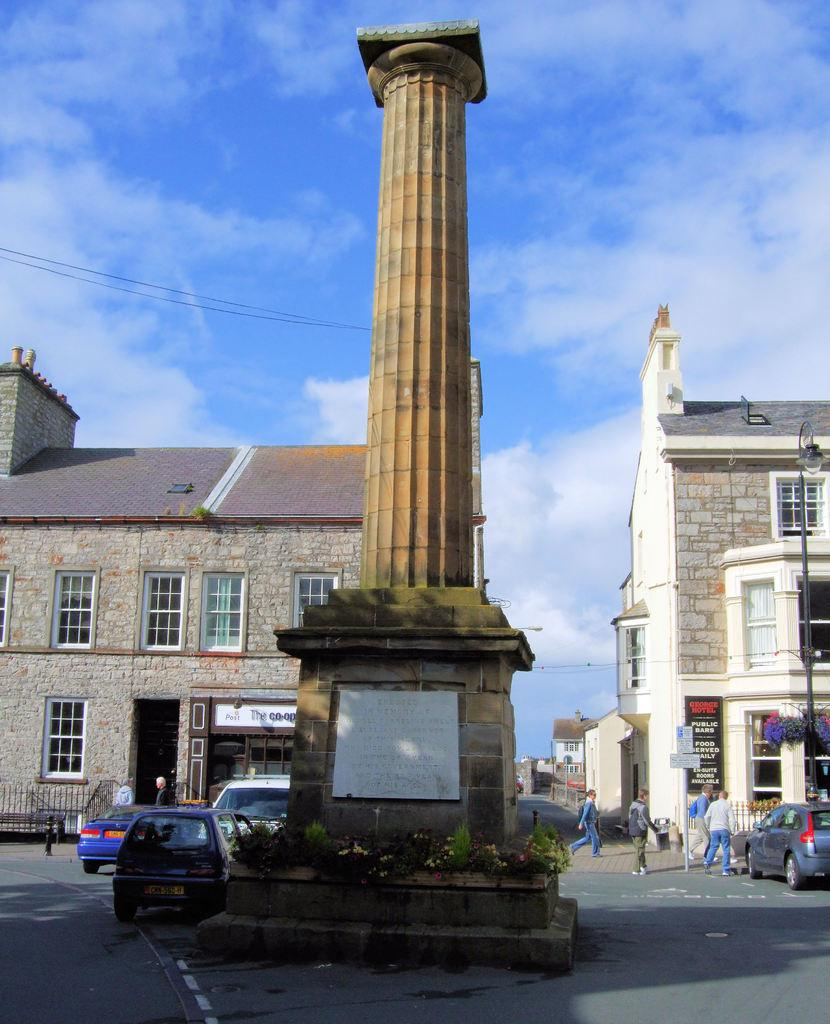What type of structures can be seen in the image? There are buildings in the image. What is the main object in the middle of the image? There is a memorial stone in the middle of the image. What mode of transportation is visible in the image? There are many cars visible in the image. Are there any people present in the image? Yes, there are people on the road in the image. What is visible in the sky at the top of the image? There are clouds in the sky at the top of the image. Can you see any chickens crossing the road in the image? There are no chickens present in the image. What type of power source is being used by the ship in the image? There is no ship present in the image. 